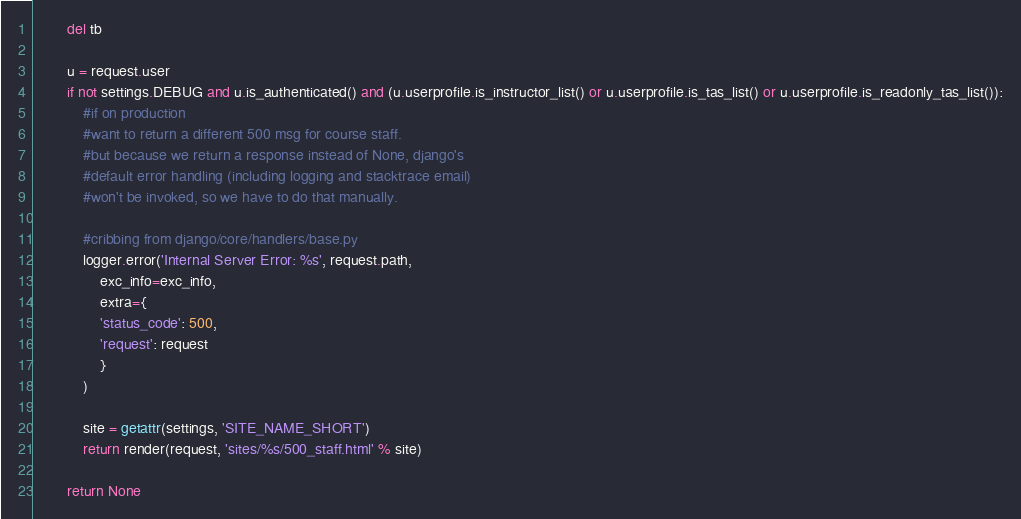Convert code to text. <code><loc_0><loc_0><loc_500><loc_500><_Python_>        del tb
    
        u = request.user
        if not settings.DEBUG and u.is_authenticated() and (u.userprofile.is_instructor_list() or u.userprofile.is_tas_list() or u.userprofile.is_readonly_tas_list()):
            #if on production
            #want to return a different 500 msg for course staff.
            #but because we return a response instead of None, django's
            #default error handling (including logging and stacktrace email)
            #won't be invoked, so we have to do that manually.
            
            #cribbing from django/core/handlers/base.py
            logger.error('Internal Server Error: %s', request.path,
                exc_info=exc_info,
                extra={
                'status_code': 500,
                'request': request
                }
            )
            
            site = getattr(settings, 'SITE_NAME_SHORT')
            return render(request, 'sites/%s/500_staff.html' % site)
                
        return None
</code> 